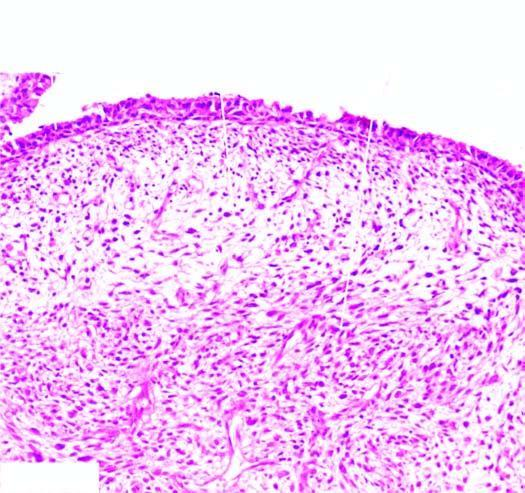what shows the characteristic submucosal cambium layer of tumour cells?
Answer the question using a single word or phrase. Tumour 